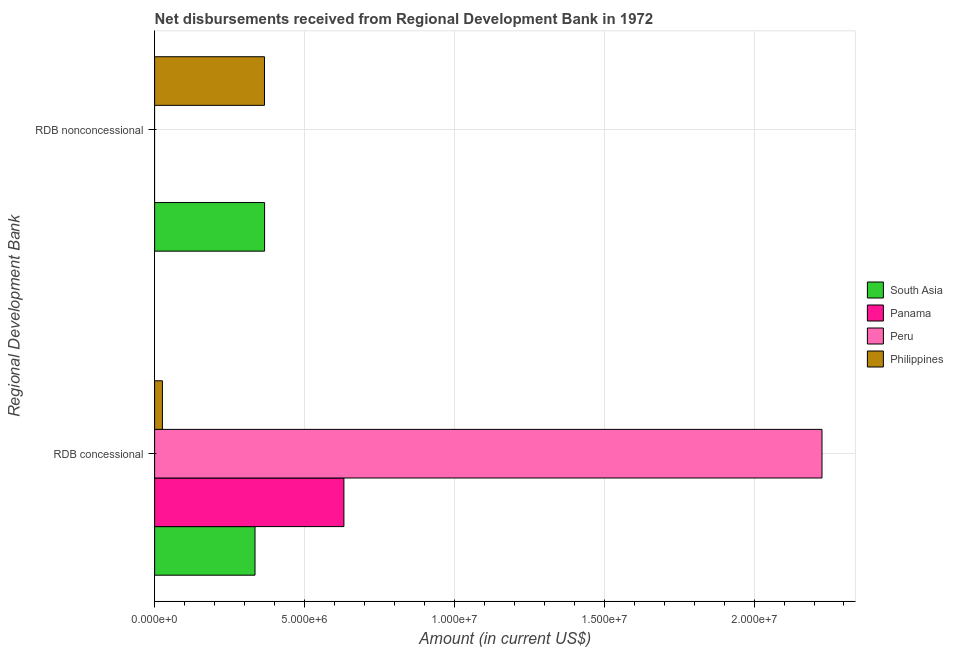How many groups of bars are there?
Offer a very short reply. 2. Are the number of bars per tick equal to the number of legend labels?
Keep it short and to the point. No. Are the number of bars on each tick of the Y-axis equal?
Offer a very short reply. No. How many bars are there on the 1st tick from the top?
Your answer should be compact. 2. What is the label of the 1st group of bars from the top?
Ensure brevity in your answer.  RDB nonconcessional. What is the net concessional disbursements from rdb in South Asia?
Your response must be concise. 3.35e+06. Across all countries, what is the maximum net concessional disbursements from rdb?
Your answer should be compact. 2.23e+07. Across all countries, what is the minimum net concessional disbursements from rdb?
Give a very brief answer. 2.61e+05. What is the total net concessional disbursements from rdb in the graph?
Keep it short and to the point. 3.22e+07. What is the difference between the net non concessional disbursements from rdb in Philippines and that in South Asia?
Provide a short and direct response. -3000. What is the difference between the net non concessional disbursements from rdb in Peru and the net concessional disbursements from rdb in Panama?
Your answer should be compact. -6.32e+06. What is the average net concessional disbursements from rdb per country?
Your answer should be very brief. 8.05e+06. What is the difference between the net non concessional disbursements from rdb and net concessional disbursements from rdb in Philippines?
Ensure brevity in your answer.  3.40e+06. In how many countries, is the net non concessional disbursements from rdb greater than 4000000 US$?
Ensure brevity in your answer.  0. What is the ratio of the net concessional disbursements from rdb in South Asia to that in Panama?
Offer a very short reply. 0.53. Is the net concessional disbursements from rdb in Peru less than that in Panama?
Make the answer very short. No. In how many countries, is the net concessional disbursements from rdb greater than the average net concessional disbursements from rdb taken over all countries?
Provide a short and direct response. 1. How many bars are there?
Offer a very short reply. 6. How many countries are there in the graph?
Offer a very short reply. 4. How many legend labels are there?
Your answer should be compact. 4. How are the legend labels stacked?
Provide a short and direct response. Vertical. What is the title of the graph?
Your answer should be compact. Net disbursements received from Regional Development Bank in 1972. What is the label or title of the Y-axis?
Ensure brevity in your answer.  Regional Development Bank. What is the Amount (in current US$) in South Asia in RDB concessional?
Offer a very short reply. 3.35e+06. What is the Amount (in current US$) in Panama in RDB concessional?
Offer a terse response. 6.32e+06. What is the Amount (in current US$) of Peru in RDB concessional?
Give a very brief answer. 2.23e+07. What is the Amount (in current US$) in Philippines in RDB concessional?
Your response must be concise. 2.61e+05. What is the Amount (in current US$) in South Asia in RDB nonconcessional?
Your response must be concise. 3.67e+06. What is the Amount (in current US$) in Panama in RDB nonconcessional?
Your answer should be compact. 0. What is the Amount (in current US$) in Philippines in RDB nonconcessional?
Offer a terse response. 3.67e+06. Across all Regional Development Bank, what is the maximum Amount (in current US$) of South Asia?
Your answer should be very brief. 3.67e+06. Across all Regional Development Bank, what is the maximum Amount (in current US$) of Panama?
Keep it short and to the point. 6.32e+06. Across all Regional Development Bank, what is the maximum Amount (in current US$) in Peru?
Your answer should be compact. 2.23e+07. Across all Regional Development Bank, what is the maximum Amount (in current US$) of Philippines?
Ensure brevity in your answer.  3.67e+06. Across all Regional Development Bank, what is the minimum Amount (in current US$) in South Asia?
Offer a terse response. 3.35e+06. Across all Regional Development Bank, what is the minimum Amount (in current US$) of Panama?
Provide a succinct answer. 0. Across all Regional Development Bank, what is the minimum Amount (in current US$) of Peru?
Give a very brief answer. 0. Across all Regional Development Bank, what is the minimum Amount (in current US$) in Philippines?
Your answer should be very brief. 2.61e+05. What is the total Amount (in current US$) in South Asia in the graph?
Make the answer very short. 7.02e+06. What is the total Amount (in current US$) in Panama in the graph?
Keep it short and to the point. 6.32e+06. What is the total Amount (in current US$) in Peru in the graph?
Provide a succinct answer. 2.23e+07. What is the total Amount (in current US$) of Philippines in the graph?
Offer a terse response. 3.93e+06. What is the difference between the Amount (in current US$) in South Asia in RDB concessional and that in RDB nonconcessional?
Give a very brief answer. -3.19e+05. What is the difference between the Amount (in current US$) of Philippines in RDB concessional and that in RDB nonconcessional?
Provide a short and direct response. -3.40e+06. What is the difference between the Amount (in current US$) in South Asia in RDB concessional and the Amount (in current US$) in Philippines in RDB nonconcessional?
Your answer should be very brief. -3.16e+05. What is the difference between the Amount (in current US$) in Panama in RDB concessional and the Amount (in current US$) in Philippines in RDB nonconcessional?
Your response must be concise. 2.65e+06. What is the difference between the Amount (in current US$) in Peru in RDB concessional and the Amount (in current US$) in Philippines in RDB nonconcessional?
Offer a very short reply. 1.86e+07. What is the average Amount (in current US$) in South Asia per Regional Development Bank?
Ensure brevity in your answer.  3.51e+06. What is the average Amount (in current US$) in Panama per Regional Development Bank?
Your answer should be compact. 3.16e+06. What is the average Amount (in current US$) in Peru per Regional Development Bank?
Provide a succinct answer. 1.11e+07. What is the average Amount (in current US$) of Philippines per Regional Development Bank?
Keep it short and to the point. 1.96e+06. What is the difference between the Amount (in current US$) in South Asia and Amount (in current US$) in Panama in RDB concessional?
Give a very brief answer. -2.97e+06. What is the difference between the Amount (in current US$) in South Asia and Amount (in current US$) in Peru in RDB concessional?
Offer a very short reply. -1.89e+07. What is the difference between the Amount (in current US$) in South Asia and Amount (in current US$) in Philippines in RDB concessional?
Ensure brevity in your answer.  3.09e+06. What is the difference between the Amount (in current US$) in Panama and Amount (in current US$) in Peru in RDB concessional?
Your response must be concise. -1.60e+07. What is the difference between the Amount (in current US$) of Panama and Amount (in current US$) of Philippines in RDB concessional?
Your response must be concise. 6.06e+06. What is the difference between the Amount (in current US$) of Peru and Amount (in current US$) of Philippines in RDB concessional?
Provide a succinct answer. 2.20e+07. What is the difference between the Amount (in current US$) in South Asia and Amount (in current US$) in Philippines in RDB nonconcessional?
Give a very brief answer. 3000. What is the ratio of the Amount (in current US$) of South Asia in RDB concessional to that in RDB nonconcessional?
Provide a short and direct response. 0.91. What is the ratio of the Amount (in current US$) of Philippines in RDB concessional to that in RDB nonconcessional?
Give a very brief answer. 0.07. What is the difference between the highest and the second highest Amount (in current US$) of South Asia?
Your answer should be very brief. 3.19e+05. What is the difference between the highest and the second highest Amount (in current US$) of Philippines?
Your answer should be compact. 3.40e+06. What is the difference between the highest and the lowest Amount (in current US$) in South Asia?
Your answer should be compact. 3.19e+05. What is the difference between the highest and the lowest Amount (in current US$) of Panama?
Provide a succinct answer. 6.32e+06. What is the difference between the highest and the lowest Amount (in current US$) in Peru?
Make the answer very short. 2.23e+07. What is the difference between the highest and the lowest Amount (in current US$) in Philippines?
Offer a very short reply. 3.40e+06. 